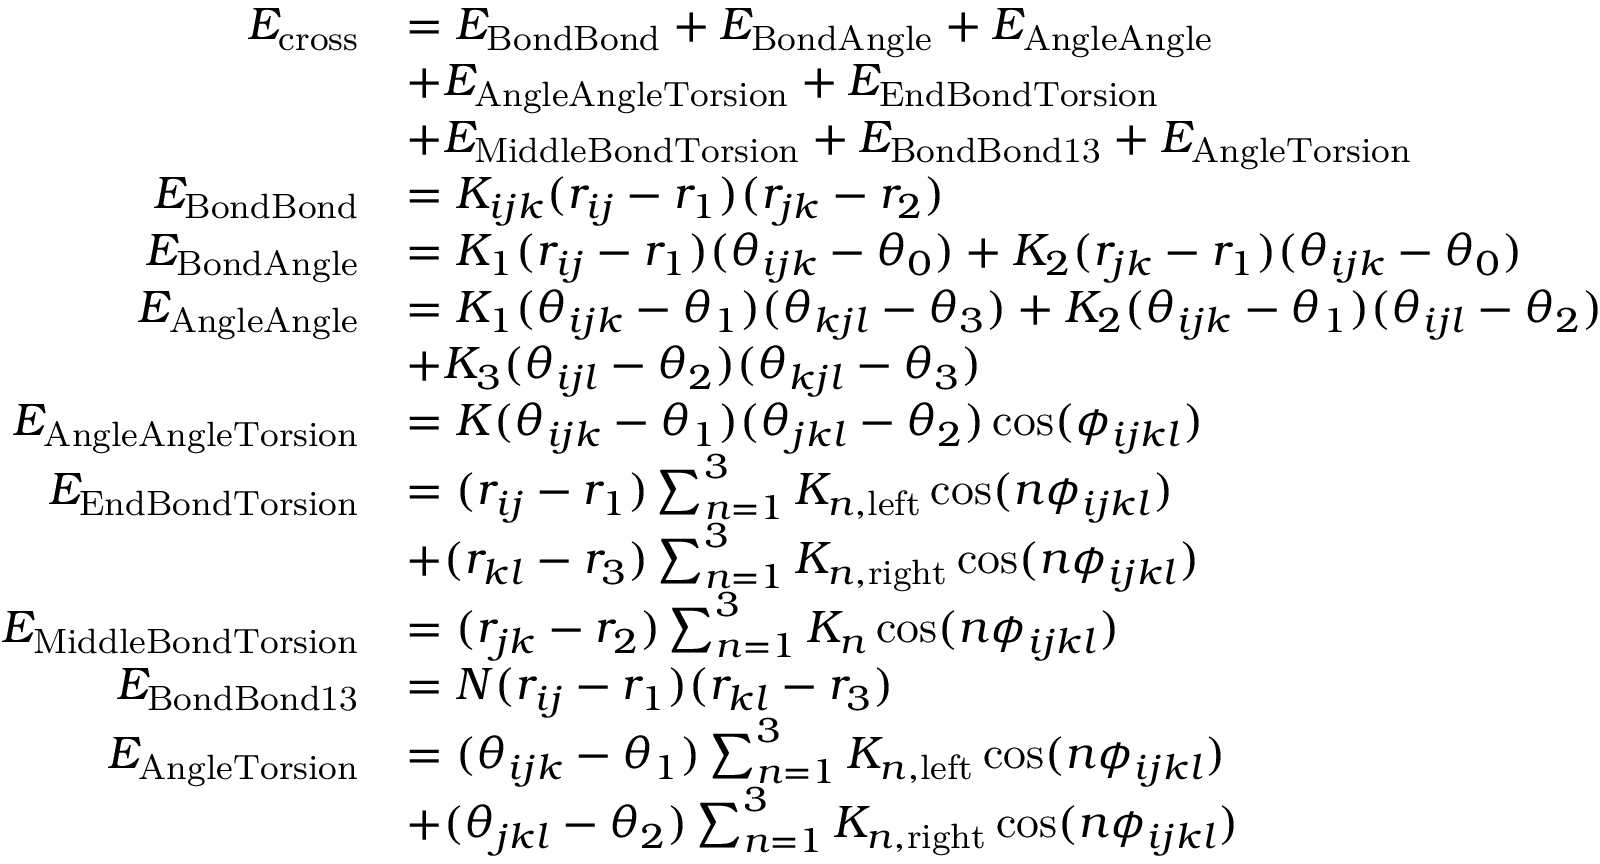Convert formula to latex. <formula><loc_0><loc_0><loc_500><loc_500>\begin{array} { r l } { E _ { c r o s s } } & { = E _ { B o n d B o n d } + E _ { B o n d A n g l e } + E _ { A n g l e A n g l e } } \\ & { + E _ { A n g l e A n g l e T o r s i o n } + E _ { E n d B o n d T o r s i o n } } \\ & { + E _ { M i d d l e B o n d T o r s i o n } + E _ { B o n d B o n d 1 3 } + E _ { A n g l e T o r s i o n } } \\ { E _ { B o n d B o n d } } & { = K _ { i j k } ( r _ { i j } - r _ { 1 } ) ( r _ { j k } - r _ { 2 } ) } \\ { E _ { B o n d A n g l e } } & { = K _ { 1 } ( r _ { i j } - r _ { 1 } ) ( \theta _ { i j k } - \theta _ { 0 } ) + K _ { 2 } ( r _ { j k } - r _ { 1 } ) ( \theta _ { i j k } - \theta _ { 0 } ) } \\ { E _ { A n g l e A n g l e } } & { = K _ { 1 } ( \theta _ { i j k } - \theta _ { 1 } ) ( \theta _ { k j l } - \theta _ { 3 } ) + K _ { 2 } ( \theta _ { i j k } - \theta _ { 1 } ) ( \theta _ { i j l } - \theta _ { 2 } ) } \\ & { + K _ { 3 } ( \theta _ { i j l } - \theta _ { 2 } ) ( \theta _ { k j l } - \theta _ { 3 } ) } \\ { E _ { A n g l e A n g l e T o r s i o n } } & { = K ( \theta _ { i j k } - \theta _ { 1 } ) ( \theta _ { j k l } - \theta _ { 2 } ) \cos ( \phi _ { i j k l } ) } \\ { E _ { E n d B o n d T o r s i o n } } & { = ( r _ { i j } - r _ { 1 } ) \sum _ { n = 1 } ^ { 3 } K _ { n , l e f t } \cos ( n \phi _ { i j k l } ) } \\ & { + ( r _ { k l } - r _ { 3 } ) \sum _ { n = 1 } ^ { 3 } K _ { n , r i g h t } \cos ( n \phi _ { i j k l } ) } \\ { E _ { M i d d l e B o n d T o r s i o n } } & { = ( r _ { j k } - r _ { 2 } ) \sum _ { n = 1 } ^ { 3 } K _ { n } \cos ( n \phi _ { i j k l } ) } \\ { E _ { B o n d B o n d 1 3 } } & { = N ( r _ { i j } - r _ { 1 } ) ( r _ { k l } - r _ { 3 } ) } \\ { E _ { A n g l e T o r s i o n } } & { = ( \theta _ { i j k } - \theta _ { 1 } ) \sum _ { n = 1 } ^ { 3 } K _ { n , l e f t } \cos ( n \phi _ { i j k l } ) } \\ & { + ( \theta _ { j k l } - \theta _ { 2 } ) \sum _ { n = 1 } ^ { 3 } K _ { n , r i g h t } \cos ( n \phi _ { i j k l } ) } \end{array}</formula> 